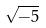Convert formula to latex. <formula><loc_0><loc_0><loc_500><loc_500>\sqrt { - 5 }</formula> 